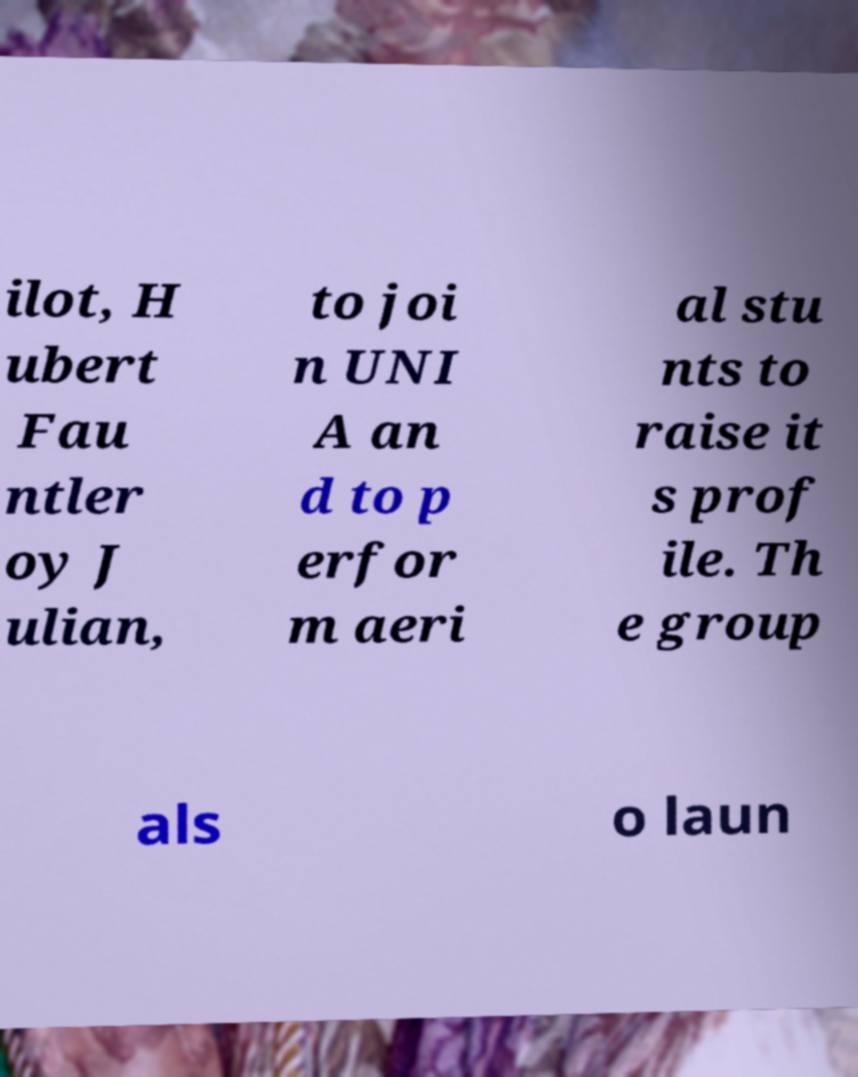For documentation purposes, I need the text within this image transcribed. Could you provide that? ilot, H ubert Fau ntler oy J ulian, to joi n UNI A an d to p erfor m aeri al stu nts to raise it s prof ile. Th e group als o laun 